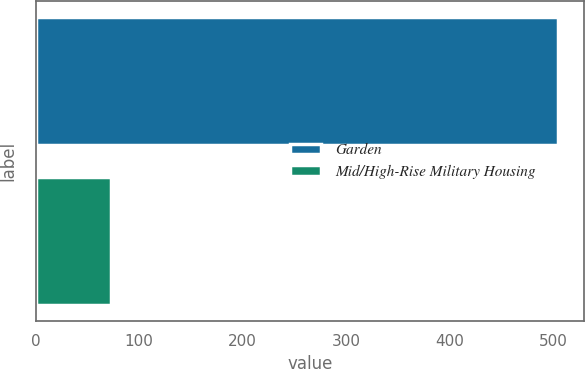Convert chart. <chart><loc_0><loc_0><loc_500><loc_500><bar_chart><fcel>Garden<fcel>Mid/High-Rise Military Housing<nl><fcel>505<fcel>73<nl></chart> 